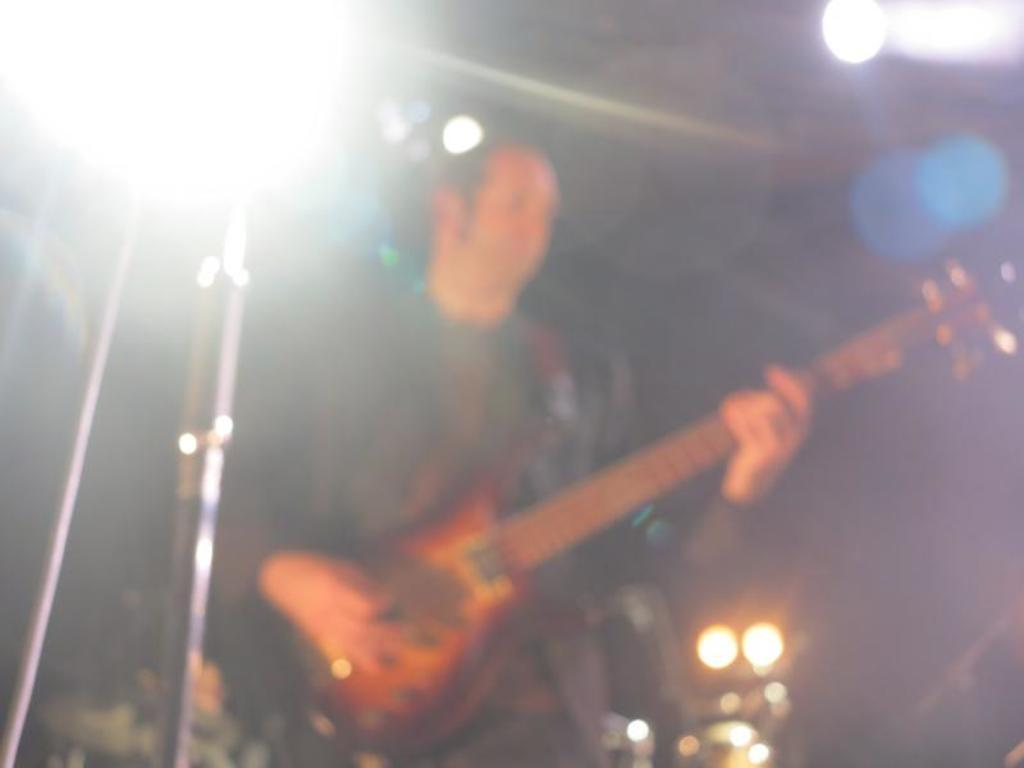What is the main subject of the image? There is a person in the image. What is the person doing in the image? The person is standing and playing a guitar. What is the person wearing in the image? The person is wearing clothes. What type of orange is being used as a pot in the image? There is no orange or pot present in the image. What is the weather like in the image? The provided facts do not mention the weather, so we cannot determine the weather from the image. 